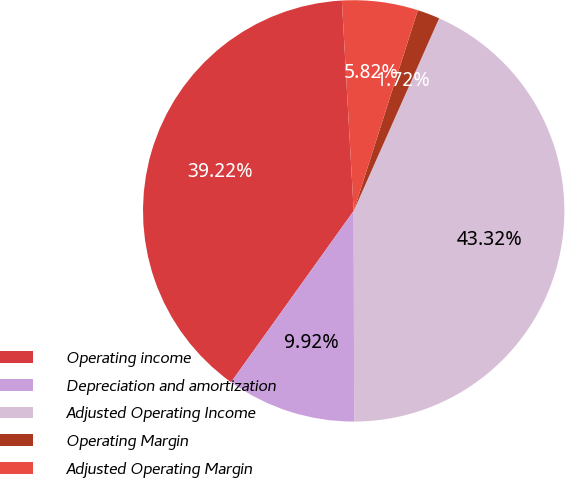Convert chart to OTSL. <chart><loc_0><loc_0><loc_500><loc_500><pie_chart><fcel>Operating income<fcel>Depreciation and amortization<fcel>Adjusted Operating Income<fcel>Operating Margin<fcel>Adjusted Operating Margin<nl><fcel>39.22%<fcel>9.92%<fcel>43.32%<fcel>1.72%<fcel>5.82%<nl></chart> 